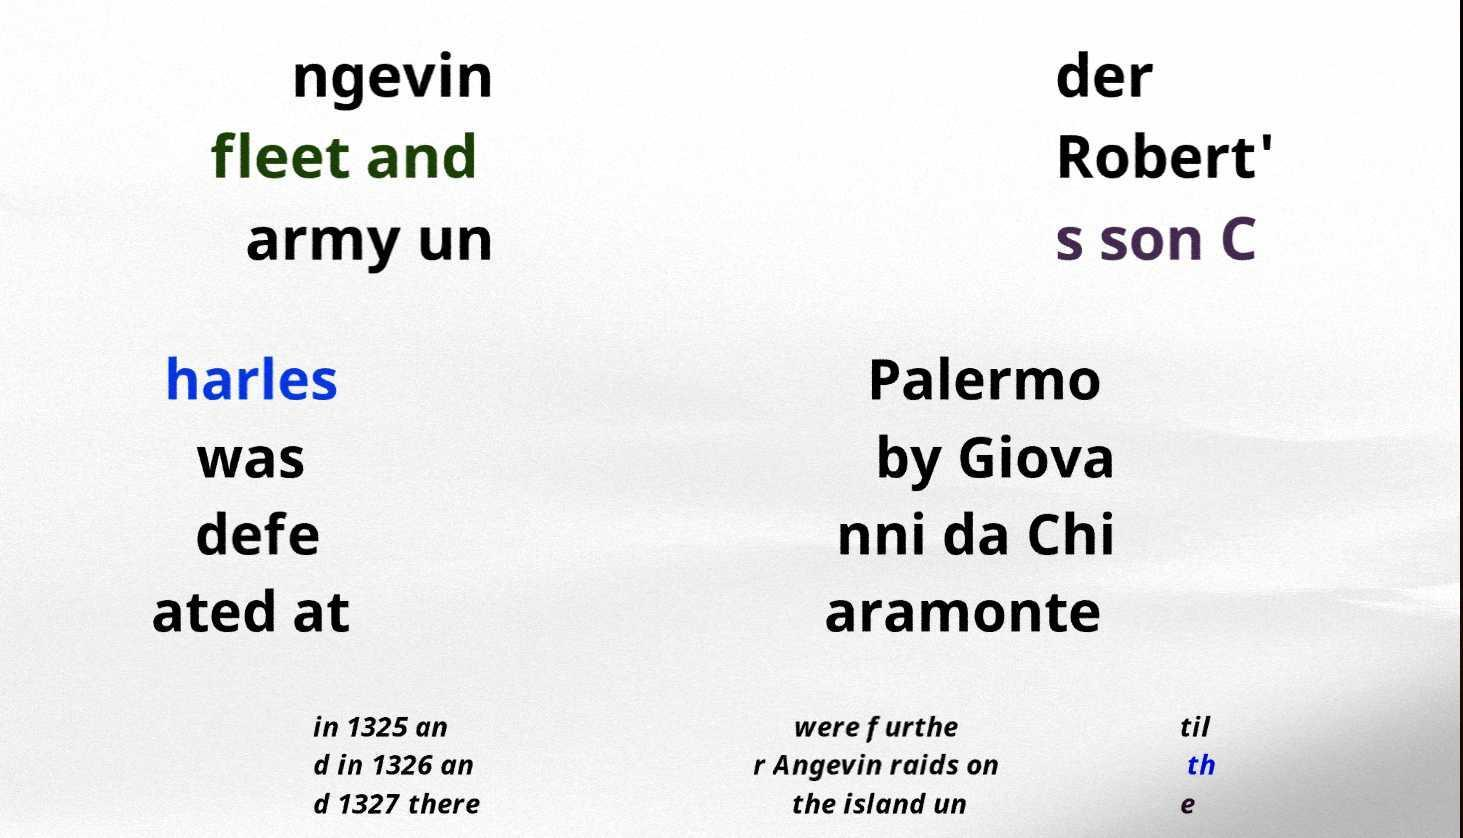Could you assist in decoding the text presented in this image and type it out clearly? ngevin fleet and army un der Robert' s son C harles was defe ated at Palermo by Giova nni da Chi aramonte in 1325 an d in 1326 an d 1327 there were furthe r Angevin raids on the island un til th e 